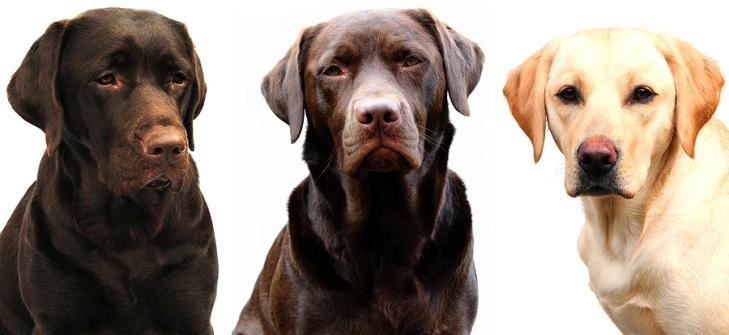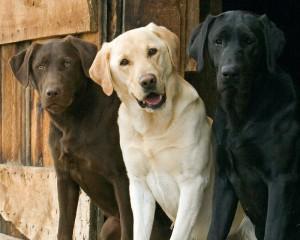The first image is the image on the left, the second image is the image on the right. Given the left and right images, does the statement "There is a total of six dogs." hold true? Answer yes or no. Yes. 